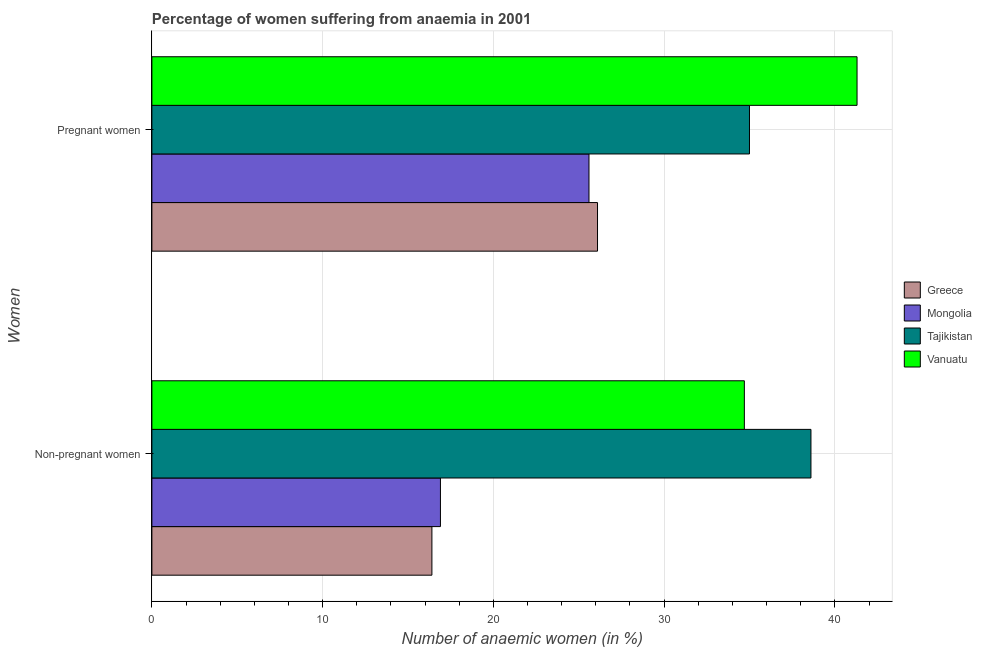How many groups of bars are there?
Your response must be concise. 2. Are the number of bars per tick equal to the number of legend labels?
Your response must be concise. Yes. How many bars are there on the 2nd tick from the top?
Provide a succinct answer. 4. How many bars are there on the 2nd tick from the bottom?
Your answer should be very brief. 4. What is the label of the 1st group of bars from the top?
Your answer should be very brief. Pregnant women. What is the percentage of pregnant anaemic women in Mongolia?
Make the answer very short. 25.6. Across all countries, what is the maximum percentage of pregnant anaemic women?
Keep it short and to the point. 41.3. Across all countries, what is the minimum percentage of non-pregnant anaemic women?
Offer a very short reply. 16.4. In which country was the percentage of non-pregnant anaemic women maximum?
Your response must be concise. Tajikistan. In which country was the percentage of pregnant anaemic women minimum?
Your response must be concise. Mongolia. What is the total percentage of pregnant anaemic women in the graph?
Give a very brief answer. 128. What is the difference between the percentage of non-pregnant anaemic women in Vanuatu and that in Tajikistan?
Provide a succinct answer. -3.9. What is the difference between the percentage of pregnant anaemic women in Vanuatu and the percentage of non-pregnant anaemic women in Tajikistan?
Provide a short and direct response. 2.7. What is the average percentage of non-pregnant anaemic women per country?
Your response must be concise. 26.65. What is the difference between the percentage of non-pregnant anaemic women and percentage of pregnant anaemic women in Tajikistan?
Offer a very short reply. 3.6. What is the ratio of the percentage of non-pregnant anaemic women in Tajikistan to that in Mongolia?
Ensure brevity in your answer.  2.28. What does the 4th bar from the top in Non-pregnant women represents?
Offer a terse response. Greece. How many bars are there?
Ensure brevity in your answer.  8. Are all the bars in the graph horizontal?
Make the answer very short. Yes. What is the difference between two consecutive major ticks on the X-axis?
Your answer should be compact. 10. Does the graph contain any zero values?
Provide a short and direct response. No. How many legend labels are there?
Provide a short and direct response. 4. How are the legend labels stacked?
Provide a short and direct response. Vertical. What is the title of the graph?
Your answer should be very brief. Percentage of women suffering from anaemia in 2001. Does "Rwanda" appear as one of the legend labels in the graph?
Your answer should be compact. No. What is the label or title of the X-axis?
Offer a terse response. Number of anaemic women (in %). What is the label or title of the Y-axis?
Your response must be concise. Women. What is the Number of anaemic women (in %) in Greece in Non-pregnant women?
Offer a terse response. 16.4. What is the Number of anaemic women (in %) of Tajikistan in Non-pregnant women?
Ensure brevity in your answer.  38.6. What is the Number of anaemic women (in %) in Vanuatu in Non-pregnant women?
Your response must be concise. 34.7. What is the Number of anaemic women (in %) in Greece in Pregnant women?
Provide a short and direct response. 26.1. What is the Number of anaemic women (in %) of Mongolia in Pregnant women?
Provide a short and direct response. 25.6. What is the Number of anaemic women (in %) of Tajikistan in Pregnant women?
Ensure brevity in your answer.  35. What is the Number of anaemic women (in %) of Vanuatu in Pregnant women?
Your response must be concise. 41.3. Across all Women, what is the maximum Number of anaemic women (in %) in Greece?
Your answer should be very brief. 26.1. Across all Women, what is the maximum Number of anaemic women (in %) of Mongolia?
Provide a short and direct response. 25.6. Across all Women, what is the maximum Number of anaemic women (in %) in Tajikistan?
Your answer should be very brief. 38.6. Across all Women, what is the maximum Number of anaemic women (in %) in Vanuatu?
Provide a succinct answer. 41.3. Across all Women, what is the minimum Number of anaemic women (in %) of Greece?
Offer a terse response. 16.4. Across all Women, what is the minimum Number of anaemic women (in %) of Mongolia?
Your response must be concise. 16.9. Across all Women, what is the minimum Number of anaemic women (in %) in Tajikistan?
Provide a short and direct response. 35. Across all Women, what is the minimum Number of anaemic women (in %) in Vanuatu?
Your answer should be very brief. 34.7. What is the total Number of anaemic women (in %) in Greece in the graph?
Ensure brevity in your answer.  42.5. What is the total Number of anaemic women (in %) of Mongolia in the graph?
Your answer should be very brief. 42.5. What is the total Number of anaemic women (in %) of Tajikistan in the graph?
Offer a terse response. 73.6. What is the difference between the Number of anaemic women (in %) in Tajikistan in Non-pregnant women and that in Pregnant women?
Offer a terse response. 3.6. What is the difference between the Number of anaemic women (in %) in Vanuatu in Non-pregnant women and that in Pregnant women?
Provide a short and direct response. -6.6. What is the difference between the Number of anaemic women (in %) in Greece in Non-pregnant women and the Number of anaemic women (in %) in Mongolia in Pregnant women?
Your answer should be very brief. -9.2. What is the difference between the Number of anaemic women (in %) in Greece in Non-pregnant women and the Number of anaemic women (in %) in Tajikistan in Pregnant women?
Make the answer very short. -18.6. What is the difference between the Number of anaemic women (in %) of Greece in Non-pregnant women and the Number of anaemic women (in %) of Vanuatu in Pregnant women?
Provide a short and direct response. -24.9. What is the difference between the Number of anaemic women (in %) in Mongolia in Non-pregnant women and the Number of anaemic women (in %) in Tajikistan in Pregnant women?
Offer a terse response. -18.1. What is the difference between the Number of anaemic women (in %) of Mongolia in Non-pregnant women and the Number of anaemic women (in %) of Vanuatu in Pregnant women?
Your answer should be very brief. -24.4. What is the average Number of anaemic women (in %) in Greece per Women?
Offer a terse response. 21.25. What is the average Number of anaemic women (in %) of Mongolia per Women?
Give a very brief answer. 21.25. What is the average Number of anaemic women (in %) in Tajikistan per Women?
Offer a very short reply. 36.8. What is the average Number of anaemic women (in %) in Vanuatu per Women?
Offer a terse response. 38. What is the difference between the Number of anaemic women (in %) of Greece and Number of anaemic women (in %) of Tajikistan in Non-pregnant women?
Provide a short and direct response. -22.2. What is the difference between the Number of anaemic women (in %) of Greece and Number of anaemic women (in %) of Vanuatu in Non-pregnant women?
Offer a terse response. -18.3. What is the difference between the Number of anaemic women (in %) of Mongolia and Number of anaemic women (in %) of Tajikistan in Non-pregnant women?
Provide a succinct answer. -21.7. What is the difference between the Number of anaemic women (in %) of Mongolia and Number of anaemic women (in %) of Vanuatu in Non-pregnant women?
Give a very brief answer. -17.8. What is the difference between the Number of anaemic women (in %) in Tajikistan and Number of anaemic women (in %) in Vanuatu in Non-pregnant women?
Provide a short and direct response. 3.9. What is the difference between the Number of anaemic women (in %) in Greece and Number of anaemic women (in %) in Mongolia in Pregnant women?
Your answer should be compact. 0.5. What is the difference between the Number of anaemic women (in %) of Greece and Number of anaemic women (in %) of Vanuatu in Pregnant women?
Your answer should be compact. -15.2. What is the difference between the Number of anaemic women (in %) in Mongolia and Number of anaemic women (in %) in Vanuatu in Pregnant women?
Your answer should be compact. -15.7. What is the ratio of the Number of anaemic women (in %) of Greece in Non-pregnant women to that in Pregnant women?
Offer a very short reply. 0.63. What is the ratio of the Number of anaemic women (in %) of Mongolia in Non-pregnant women to that in Pregnant women?
Your response must be concise. 0.66. What is the ratio of the Number of anaemic women (in %) of Tajikistan in Non-pregnant women to that in Pregnant women?
Your response must be concise. 1.1. What is the ratio of the Number of anaemic women (in %) in Vanuatu in Non-pregnant women to that in Pregnant women?
Keep it short and to the point. 0.84. What is the difference between the highest and the second highest Number of anaemic women (in %) of Tajikistan?
Make the answer very short. 3.6. What is the difference between the highest and the second highest Number of anaemic women (in %) in Vanuatu?
Your response must be concise. 6.6. What is the difference between the highest and the lowest Number of anaemic women (in %) of Mongolia?
Your answer should be compact. 8.7. What is the difference between the highest and the lowest Number of anaemic women (in %) in Vanuatu?
Your answer should be very brief. 6.6. 